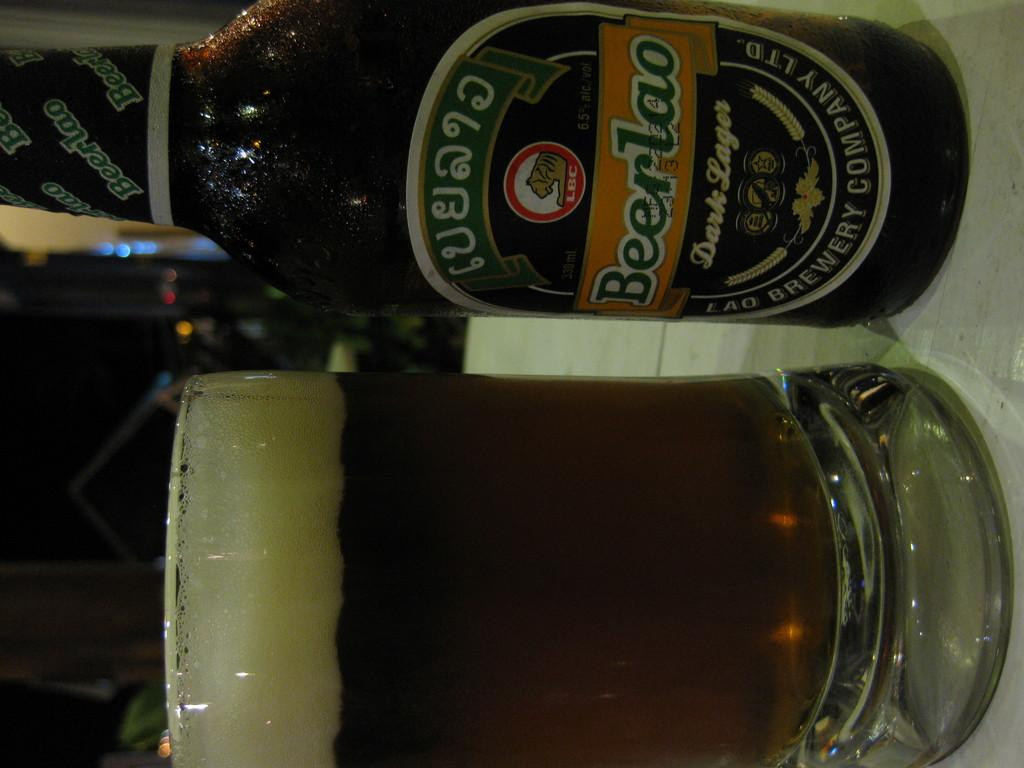Provide a one-sentence caption for the provided image. A bottle of Beerlao dark lager is placed next to a beer mug. 